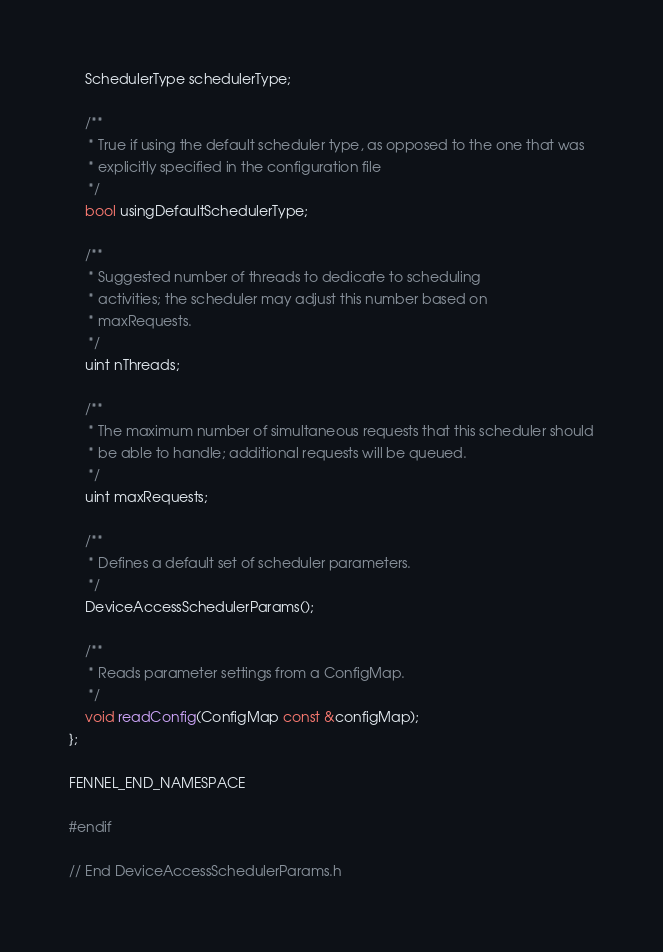Convert code to text. <code><loc_0><loc_0><loc_500><loc_500><_C_>    SchedulerType schedulerType;

    /**
     * True if using the default scheduler type, as opposed to the one that was
     * explicitly specified in the configuration file
     */
    bool usingDefaultSchedulerType;

    /**
     * Suggested number of threads to dedicate to scheduling
     * activities; the scheduler may adjust this number based on
     * maxRequests.
     */
    uint nThreads;

    /**
     * The maximum number of simultaneous requests that this scheduler should
     * be able to handle; additional requests will be queued.
     */
    uint maxRequests;

    /**
     * Defines a default set of scheduler parameters.
     */
    DeviceAccessSchedulerParams();

    /**
     * Reads parameter settings from a ConfigMap.
     */
    void readConfig(ConfigMap const &configMap);
};

FENNEL_END_NAMESPACE

#endif

// End DeviceAccessSchedulerParams.h
</code> 